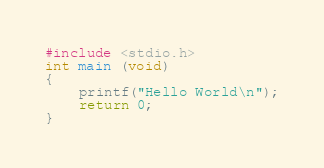Convert code to text. <code><loc_0><loc_0><loc_500><loc_500><_C_>#include <stdio.h>
int main (void)
{
	printf("Hello World\n");
	return 0;
}</code> 